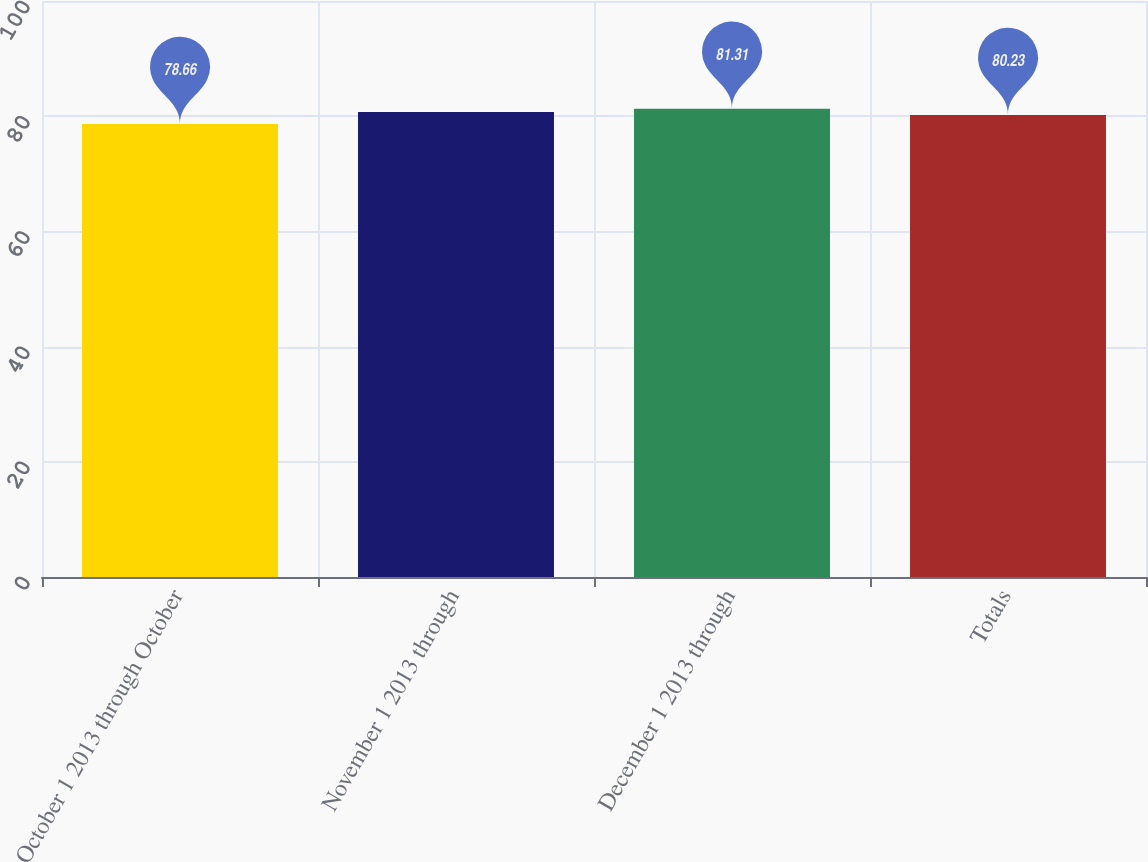<chart> <loc_0><loc_0><loc_500><loc_500><bar_chart><fcel>October 1 2013 through October<fcel>November 1 2013 through<fcel>December 1 2013 through<fcel>Totals<nl><fcel>78.66<fcel>80.71<fcel>81.31<fcel>80.23<nl></chart> 